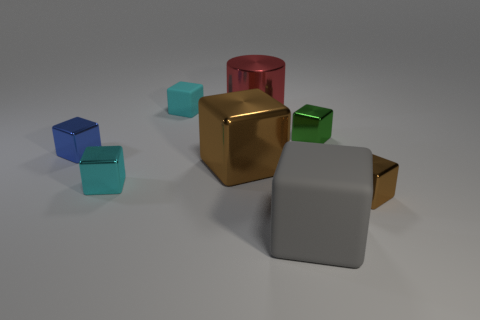The big shiny object that is the same shape as the tiny brown thing is what color?
Give a very brief answer. Brown. How many tiny blocks are both on the left side of the cyan metallic block and to the right of the blue cube?
Provide a succinct answer. 0. Are there more matte cubes that are left of the gray object than big gray matte blocks behind the large brown object?
Give a very brief answer. Yes. How big is the blue metallic object?
Provide a succinct answer. Small. Are there any cyan shiny things of the same shape as the tiny blue thing?
Give a very brief answer. Yes. Does the big brown metal thing have the same shape as the matte object that is behind the gray matte block?
Keep it short and to the point. Yes. There is a shiny thing that is both right of the big gray matte thing and behind the tiny brown metal block; what size is it?
Offer a terse response. Small. How many big blue metallic cylinders are there?
Offer a terse response. 0. There is a brown cube that is the same size as the blue block; what material is it?
Provide a succinct answer. Metal. Is there a gray metallic cube that has the same size as the metallic cylinder?
Your answer should be very brief. No. 